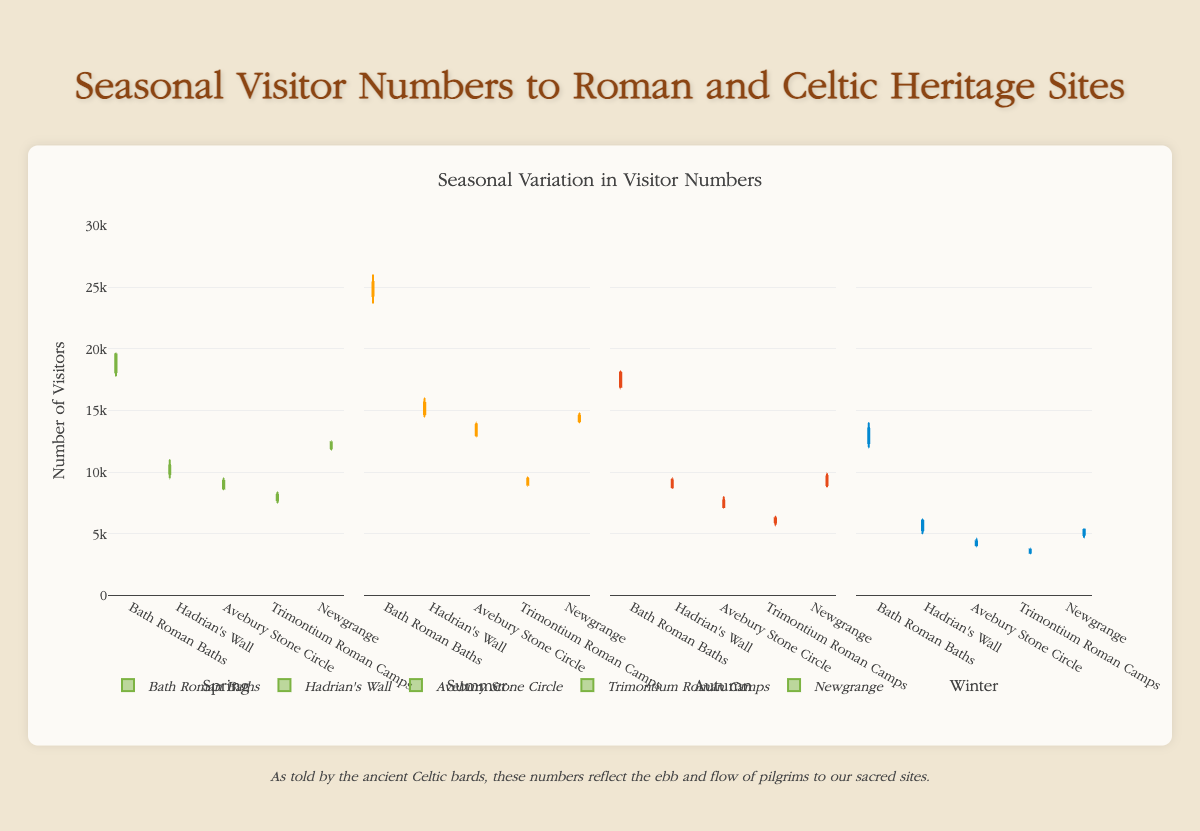What is the title of the figure? The title of the figure is usually positioned at the top of a chart to provide a summary of the information being displayed. In this figure, the title reads "Seasonal Visitor Numbers to Roman and Celtic Heritage Sites."
Answer: "Seasonal Visitor Numbers to Roman and Celtic Heritage Sites" Which season shows the highest median visitor numbers for Bath Roman Baths? To find the season with the highest median for Bath Roman Baths, look for the box plot with the highest horizontal line inside the box. This line represents the median. In this case, Summer shows the highest median visitor numbers.
Answer: Summer How do the visitor numbers compare between Hadrian's Wall and Avebury Stone Circle in Winter? To compare the visitor numbers in Winter between Hadrian's Wall and Avebury Stone Circle, look at the position and range of their respective box plots. Hadrian's Wall has a higher median and overall higher range of visitor numbers compared to Avebury Stone Circle.
Answer: Hadrian's Wall has higher visitor numbers What's the range of visitor numbers for Newgrange in Spring? The range in a box plot is determined by the difference between the largest and smallest values. For Newgrange in Spring, the minimum visitor number is 11800 and the maximum is 12500. So, the range is 12500 - 11800.
Answer: 700 Which season has the smallest interquartile range for visitor numbers at Trimontium Roman Camps? The interquartile range (IQR) is represented by the height of the box in the box plot. To find the smallest IQR, look for the shortest box. For Trimontium Roman Camps, Winter has the smallest interquartile range.
Answer: Winter In which season is the variability in visitor numbers the highest for Avebury Stone Circle? Variability is indicated by the length of the whiskers and the spread within the box of the box plot. To determine the highest variability, look for the longest box or whiskers. For Avebury Stone Circle, Summer shows the highest variability.
Answer: Summer Compare the median visitor numbers for all heritage sites in Autumn. Which site has the highest and which has the lowest median? To compare the medians, look at the horizontal lines inside the boxes in Autumn for each site. Bath Roman Baths has the highest median and Trimontium Roman Camps has the lowest median visitor numbers in Autumn.
Answer: Bath Roman Baths highest, Trimontium Roman Camps lowest What can you deduce about seasonal visitor patterns across all sites? By observing the plots for all sites, it is evident that Summer generally has the highest visitor numbers, while Winter has the lowest across all sites. This suggests that more people visit these heritage sites during the warmer months.
Answer: Higher visitors in Summer, lower in Winter How many more visitors does the median in Summer at Bath Roman Baths have compared to the median in Winter? The median visitor numbers in Summer and Winter for Bath Roman Baths can be compared directly. The median in Summer is around 24900, whereas in Winter it is around 13000. The difference is 24900 - 13000.
Answer: 11900 more visitors 